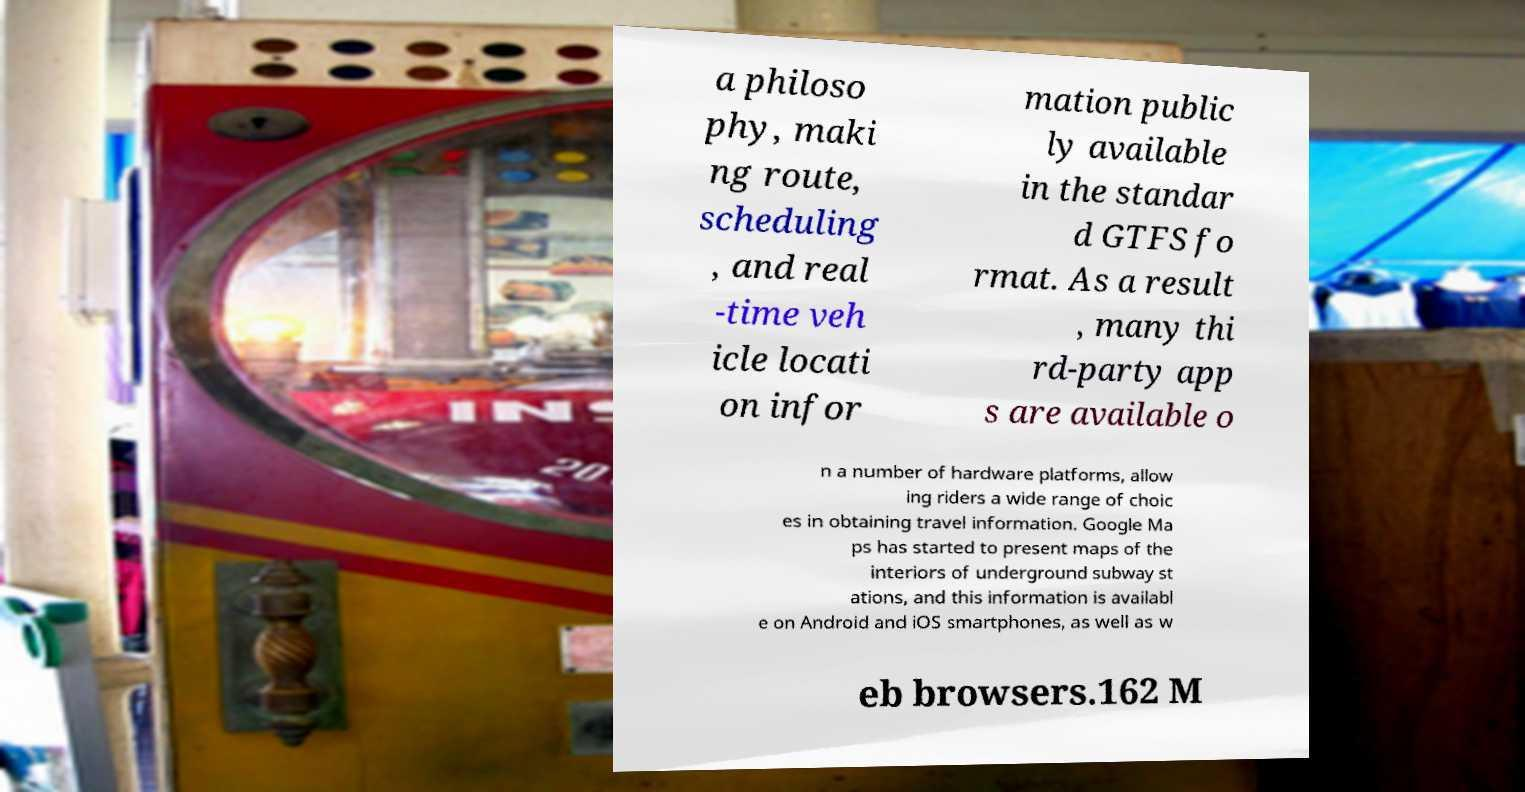For documentation purposes, I need the text within this image transcribed. Could you provide that? a philoso phy, maki ng route, scheduling , and real -time veh icle locati on infor mation public ly available in the standar d GTFS fo rmat. As a result , many thi rd-party app s are available o n a number of hardware platforms, allow ing riders a wide range of choic es in obtaining travel information. Google Ma ps has started to present maps of the interiors of underground subway st ations, and this information is availabl e on Android and iOS smartphones, as well as w eb browsers.162 M 